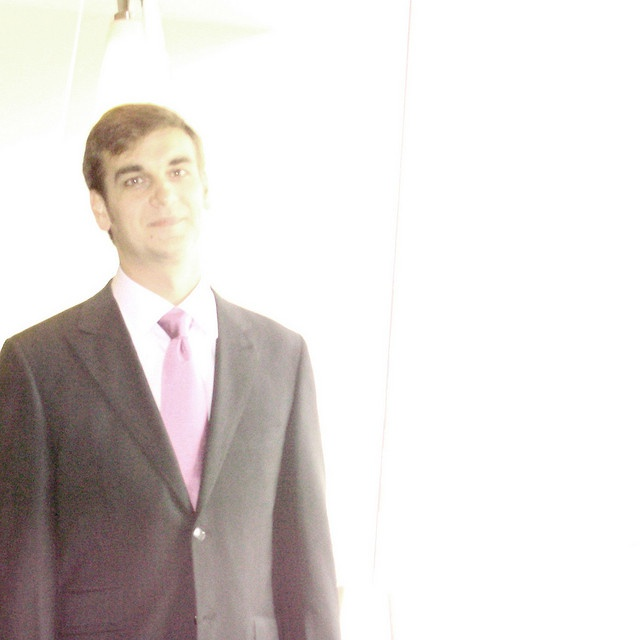Describe the objects in this image and their specific colors. I can see people in ivory, gray, darkgray, and white tones and tie in ivory, pink, and lightpink tones in this image. 